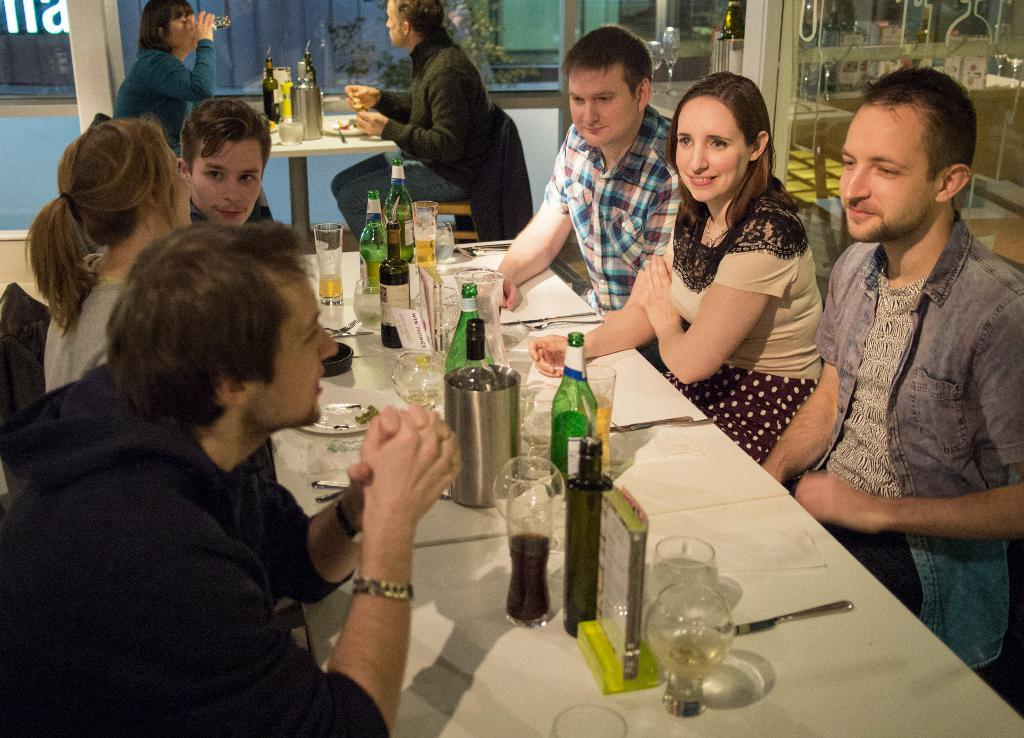What type of setting is depicted in the image? The image is an indoor scene. What are the persons in the image doing? The persons in the image are sitting on chairs. What objects are in front of the persons? There are tables in front of the persons. What items can be seen on the table? There are bottles, glasses, plates, and spoons on the table. What type of education is being taught in the image? There is no indication of education being taught in the image; it depicts persons sitting at a table with various items. Can you see a brush in the image? There is no brush visible in the image. 